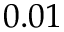Convert formula to latex. <formula><loc_0><loc_0><loc_500><loc_500>0 . 0 1</formula> 